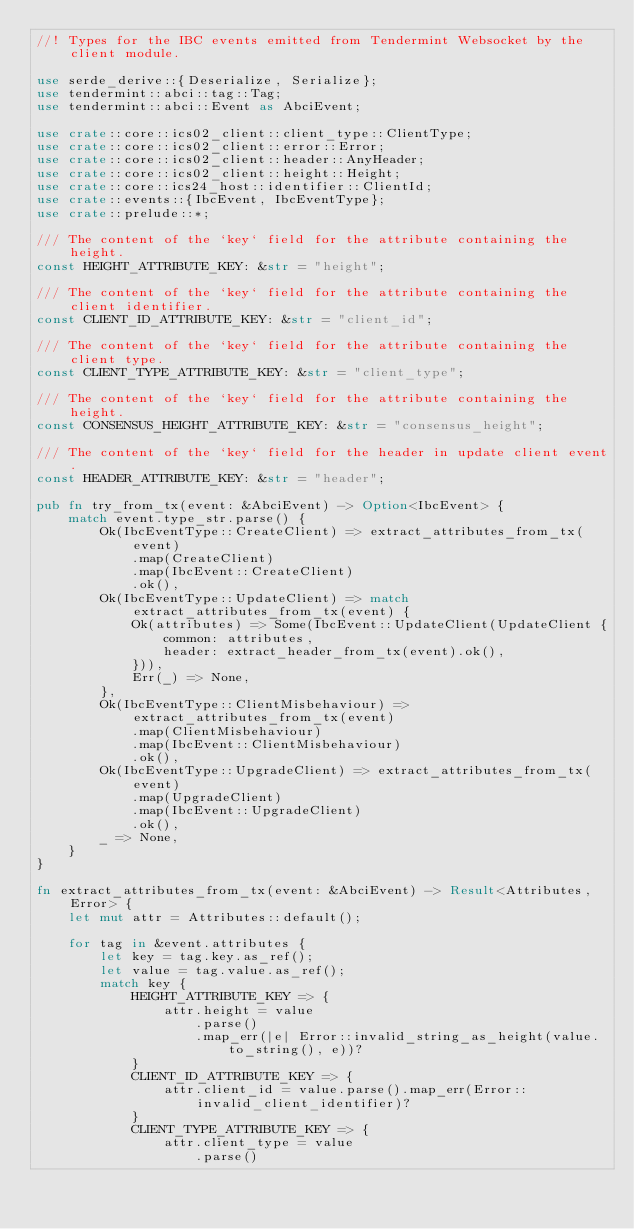<code> <loc_0><loc_0><loc_500><loc_500><_Rust_>//! Types for the IBC events emitted from Tendermint Websocket by the client module.

use serde_derive::{Deserialize, Serialize};
use tendermint::abci::tag::Tag;
use tendermint::abci::Event as AbciEvent;

use crate::core::ics02_client::client_type::ClientType;
use crate::core::ics02_client::error::Error;
use crate::core::ics02_client::header::AnyHeader;
use crate::core::ics02_client::height::Height;
use crate::core::ics24_host::identifier::ClientId;
use crate::events::{IbcEvent, IbcEventType};
use crate::prelude::*;

/// The content of the `key` field for the attribute containing the height.
const HEIGHT_ATTRIBUTE_KEY: &str = "height";

/// The content of the `key` field for the attribute containing the client identifier.
const CLIENT_ID_ATTRIBUTE_KEY: &str = "client_id";

/// The content of the `key` field for the attribute containing the client type.
const CLIENT_TYPE_ATTRIBUTE_KEY: &str = "client_type";

/// The content of the `key` field for the attribute containing the height.
const CONSENSUS_HEIGHT_ATTRIBUTE_KEY: &str = "consensus_height";

/// The content of the `key` field for the header in update client event.
const HEADER_ATTRIBUTE_KEY: &str = "header";

pub fn try_from_tx(event: &AbciEvent) -> Option<IbcEvent> {
    match event.type_str.parse() {
        Ok(IbcEventType::CreateClient) => extract_attributes_from_tx(event)
            .map(CreateClient)
            .map(IbcEvent::CreateClient)
            .ok(),
        Ok(IbcEventType::UpdateClient) => match extract_attributes_from_tx(event) {
            Ok(attributes) => Some(IbcEvent::UpdateClient(UpdateClient {
                common: attributes,
                header: extract_header_from_tx(event).ok(),
            })),
            Err(_) => None,
        },
        Ok(IbcEventType::ClientMisbehaviour) => extract_attributes_from_tx(event)
            .map(ClientMisbehaviour)
            .map(IbcEvent::ClientMisbehaviour)
            .ok(),
        Ok(IbcEventType::UpgradeClient) => extract_attributes_from_tx(event)
            .map(UpgradeClient)
            .map(IbcEvent::UpgradeClient)
            .ok(),
        _ => None,
    }
}

fn extract_attributes_from_tx(event: &AbciEvent) -> Result<Attributes, Error> {
    let mut attr = Attributes::default();

    for tag in &event.attributes {
        let key = tag.key.as_ref();
        let value = tag.value.as_ref();
        match key {
            HEIGHT_ATTRIBUTE_KEY => {
                attr.height = value
                    .parse()
                    .map_err(|e| Error::invalid_string_as_height(value.to_string(), e))?
            }
            CLIENT_ID_ATTRIBUTE_KEY => {
                attr.client_id = value.parse().map_err(Error::invalid_client_identifier)?
            }
            CLIENT_TYPE_ATTRIBUTE_KEY => {
                attr.client_type = value
                    .parse()</code> 